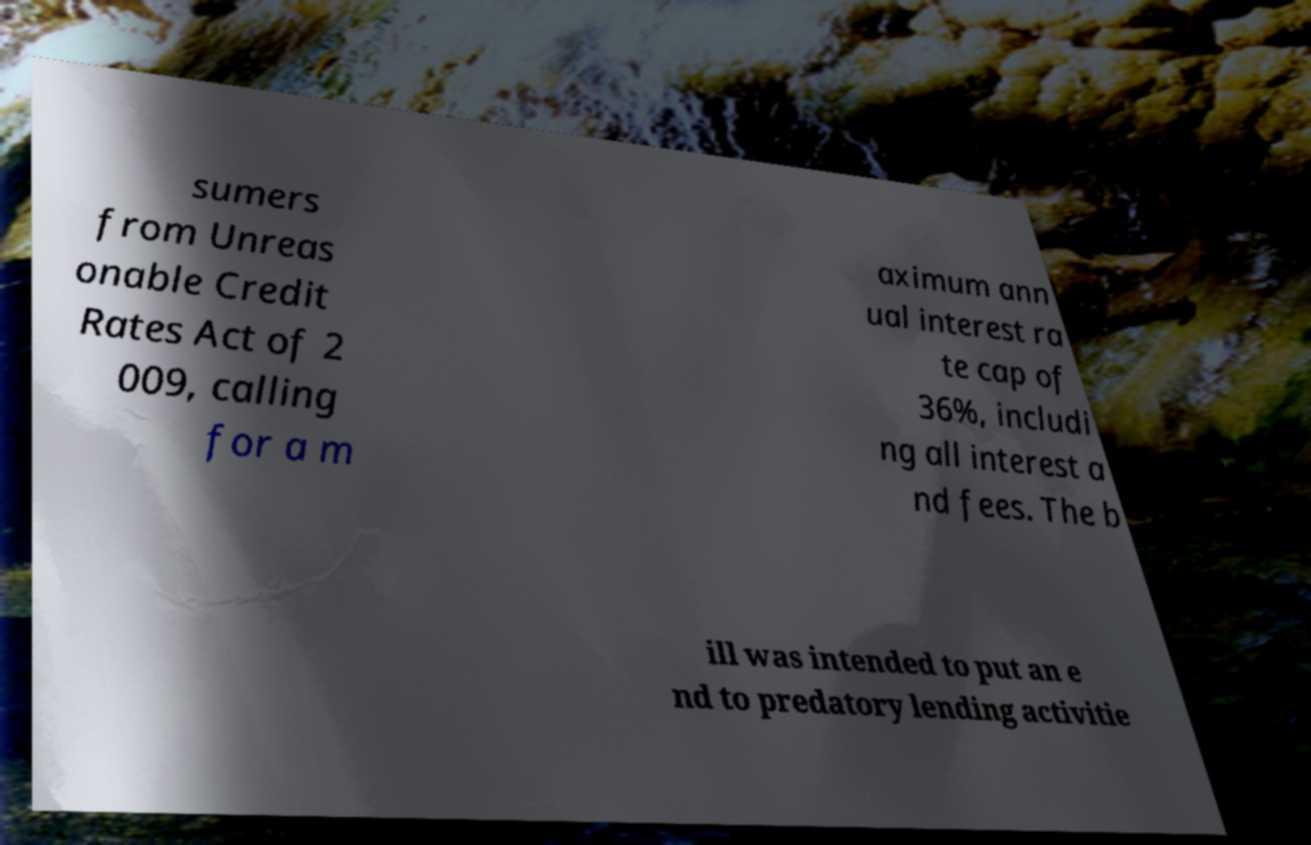Please identify and transcribe the text found in this image. sumers from Unreas onable Credit Rates Act of 2 009, calling for a m aximum ann ual interest ra te cap of 36%, includi ng all interest a nd fees. The b ill was intended to put an e nd to predatory lending activitie 